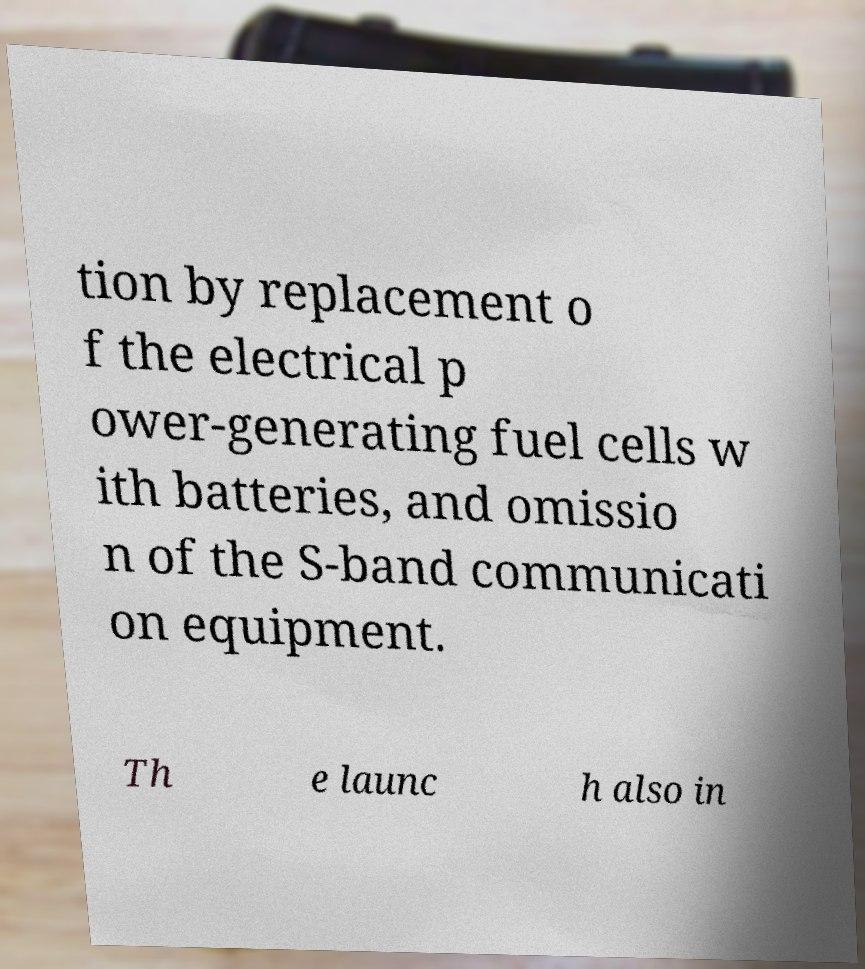Can you accurately transcribe the text from the provided image for me? tion by replacement o f the electrical p ower-generating fuel cells w ith batteries, and omissio n of the S-band communicati on equipment. Th e launc h also in 